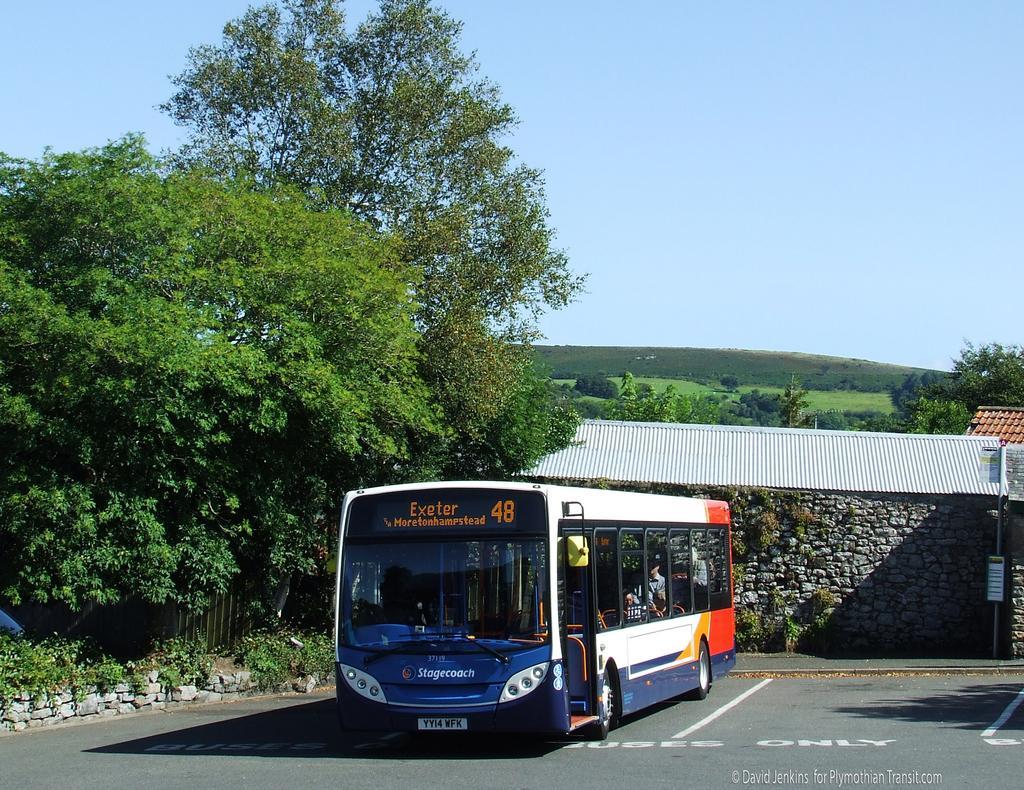Please provide a concise description of this image. As we can see in the image there are trees, bus, houses, grass and sky. 